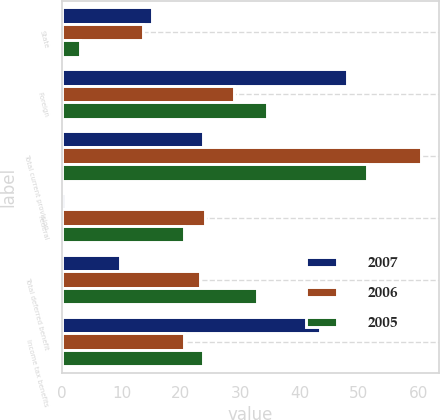<chart> <loc_0><loc_0><loc_500><loc_500><stacked_bar_chart><ecel><fcel>State<fcel>Foreign<fcel>Total current provision<fcel>Federal<fcel>Total deferred benefit<fcel>Income tax benefits<nl><fcel>2007<fcel>15.2<fcel>48<fcel>23.7<fcel>0.5<fcel>9.8<fcel>43.5<nl><fcel>2006<fcel>13.6<fcel>29<fcel>60.5<fcel>24.1<fcel>23.3<fcel>20.6<nl><fcel>2005<fcel>3<fcel>34.6<fcel>51.3<fcel>20.6<fcel>32.8<fcel>23.7<nl></chart> 